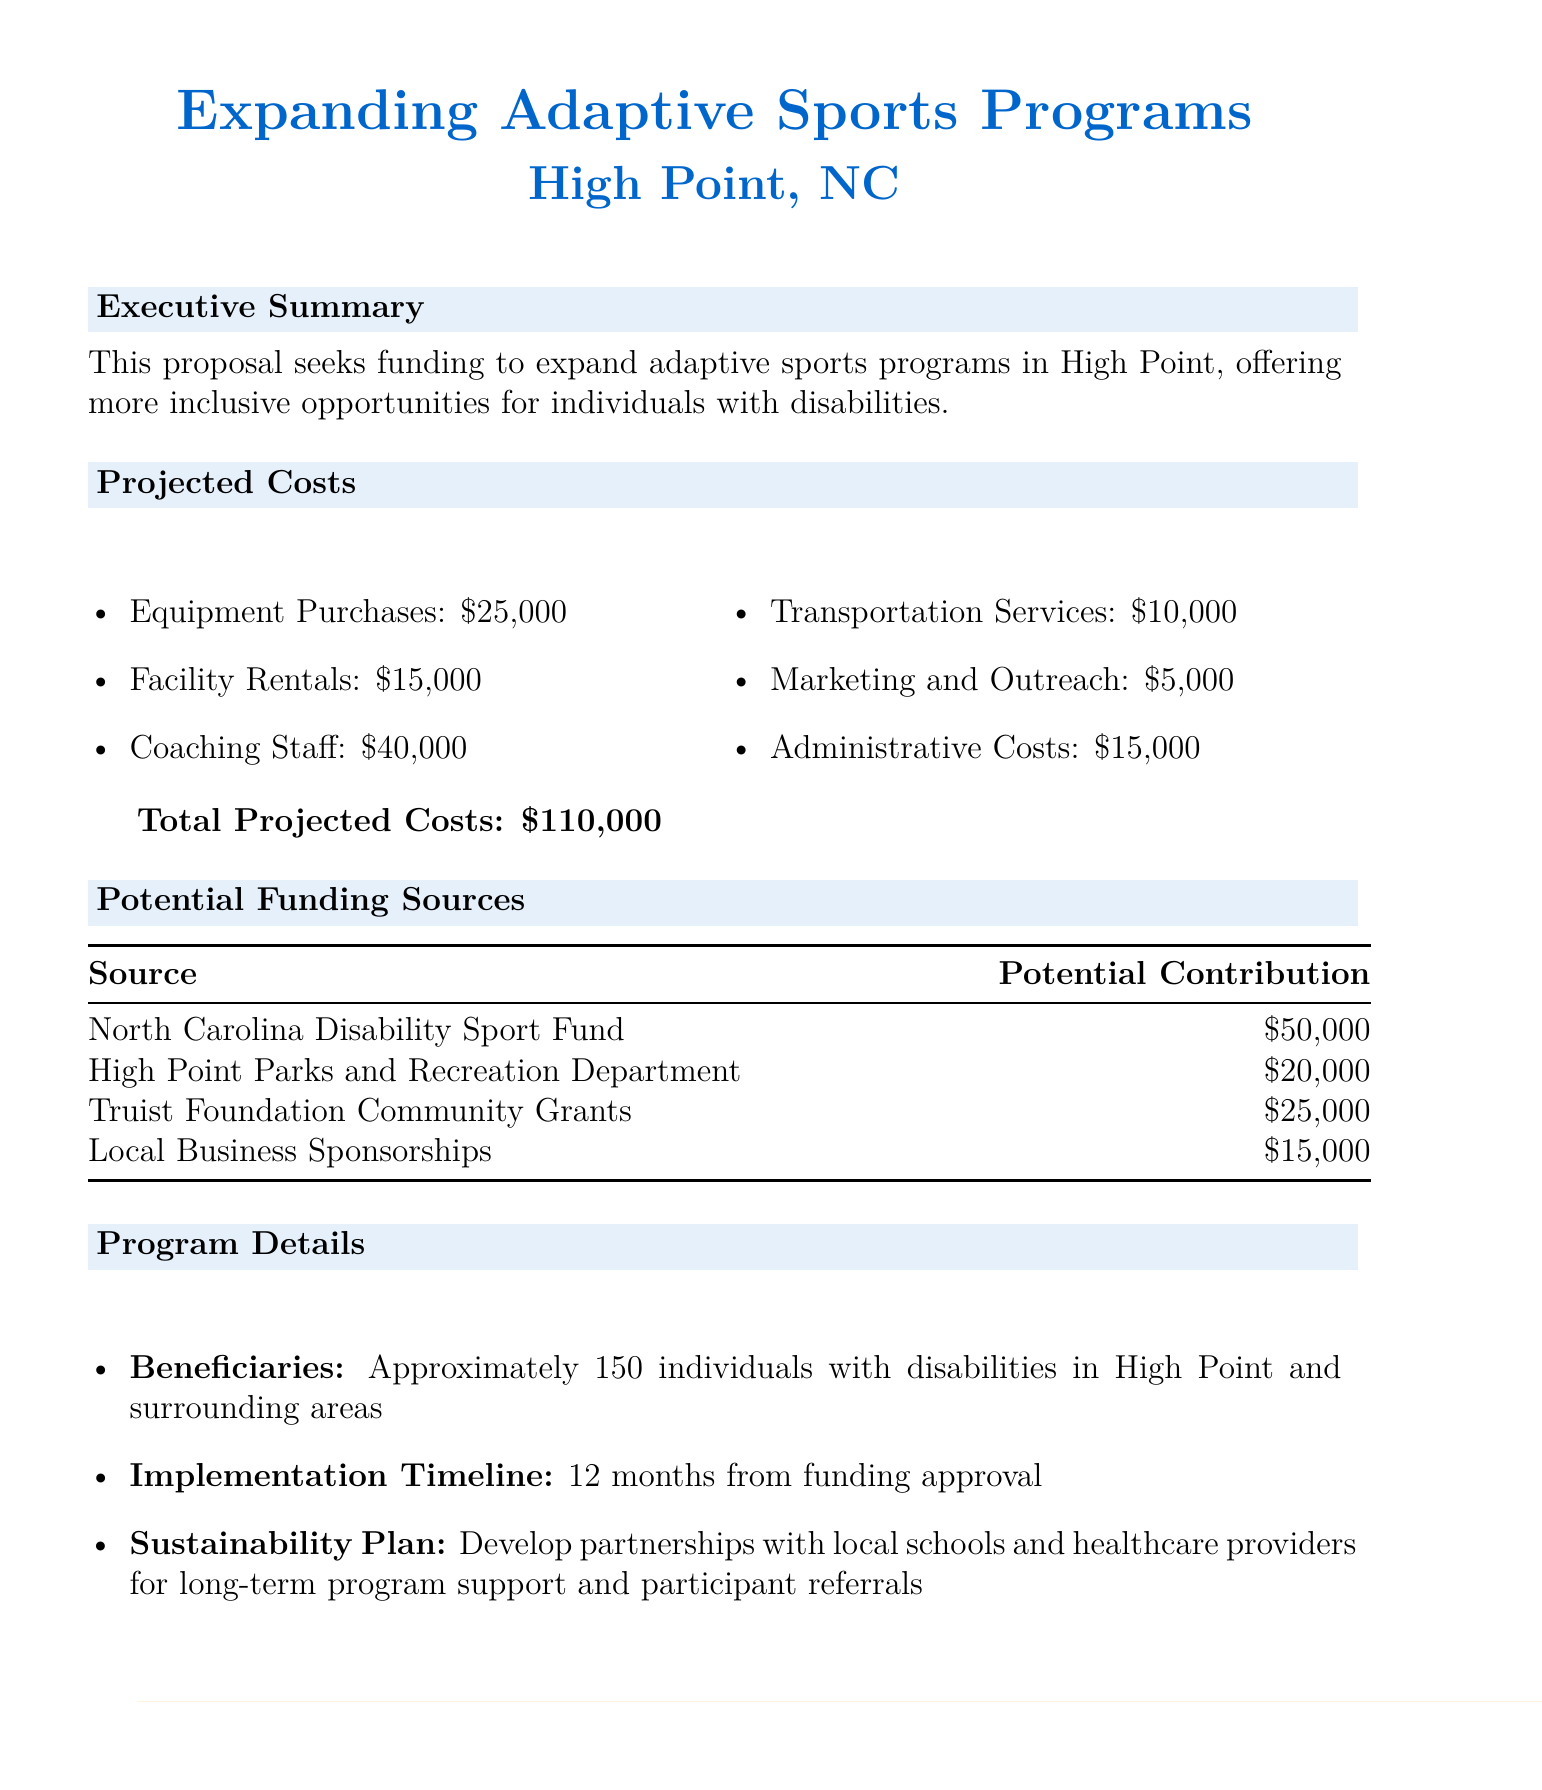What is the project title? The project title is explicitly stated at the beginning of the document as part of the header information.
Answer: Expanding Adaptive Sports Programs in High Point, NC What is the total projected cost for the program? The total projected cost is outlined in the section dedicated to projected costs.
Answer: $110,000 How many individuals with disabilities will benefit from the program? The document specifies the number of individuals expected to benefit in the program details section.
Answer: Approximately 150 What is the potential contribution from the Truist Foundation Community Grants? This information is found in the table listing potential funding sources and their contributions.
Answer: $25,000 What is the implementation timeline for the project? The implementation timeline is provided in the program details section of the document.
Answer: 12 months from funding approval What is one element of the sustainability plan? The sustainability plan outlines strategies for long-term support and is described in the program details section.
Answer: Develop partnerships with local schools and healthcare providers Which funding source is expected to contribute the most? This information can be found in the potential funding sources table, showing the highest amount.
Answer: North Carolina Disability Sport Fund What is the total potential funding expected from Local Business Sponsorships? The potential funding amount from local business sponsorships is detailed in the funding sources table.
Answer: $15,000 